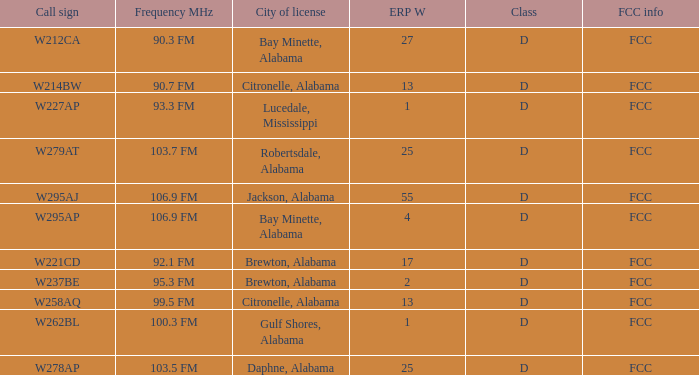Name the frequence MHz for ERP W of 55 106.9 FM. 